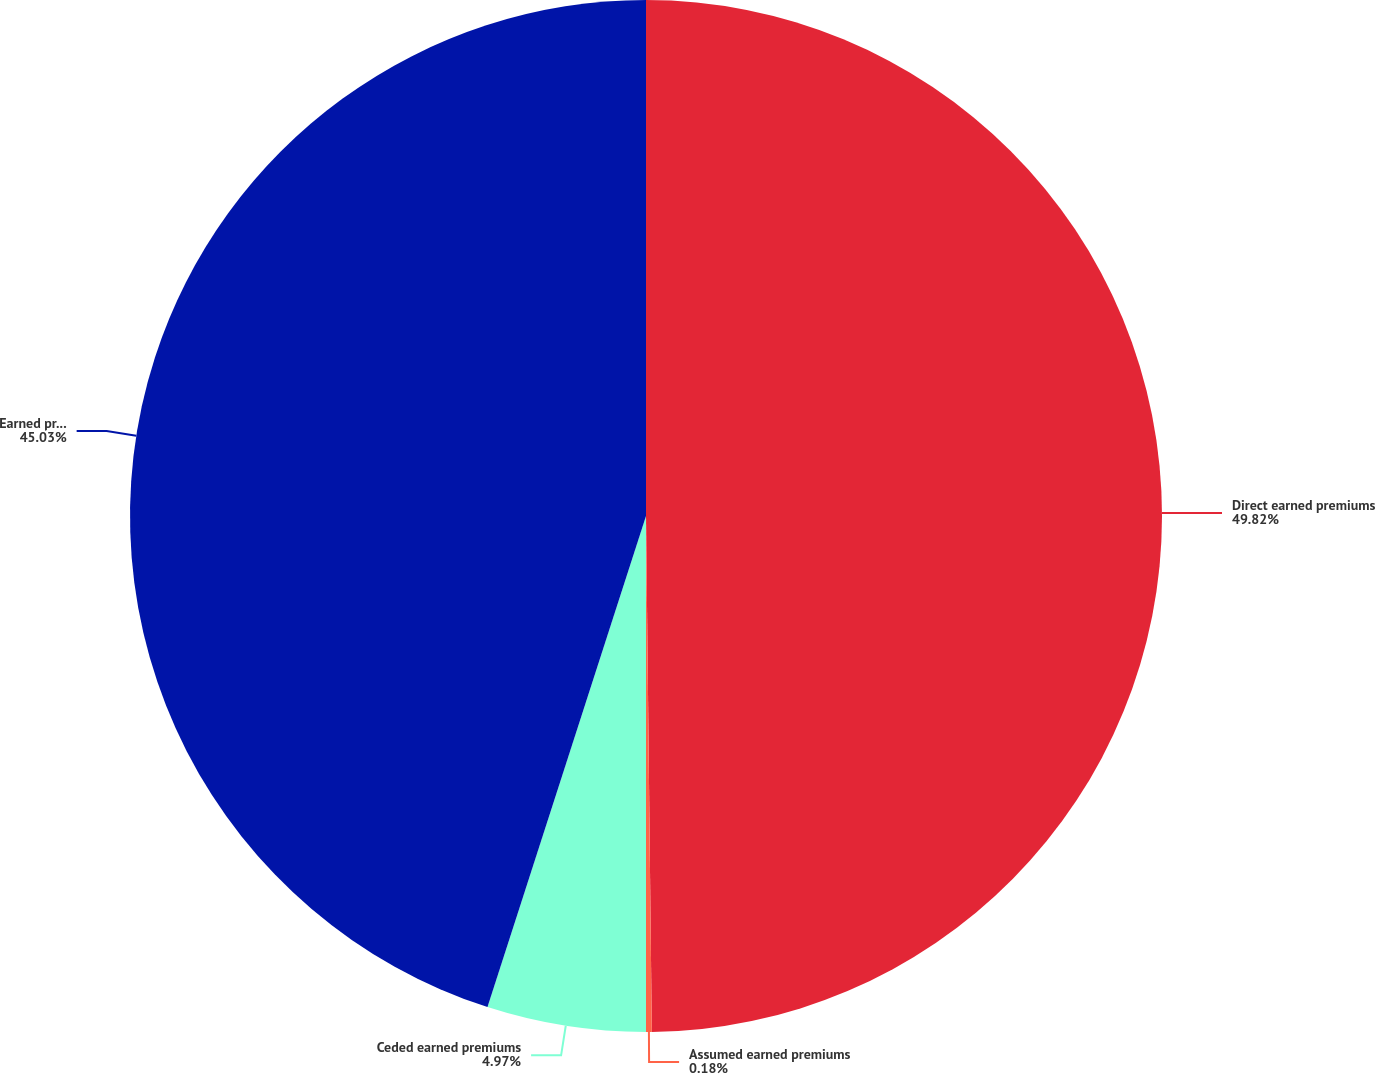<chart> <loc_0><loc_0><loc_500><loc_500><pie_chart><fcel>Direct earned premiums<fcel>Assumed earned premiums<fcel>Ceded earned premiums<fcel>Earned premiums<nl><fcel>49.82%<fcel>0.18%<fcel>4.97%<fcel>45.03%<nl></chart> 